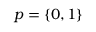Convert formula to latex. <formula><loc_0><loc_0><loc_500><loc_500>p = \{ 0 , 1 \}</formula> 